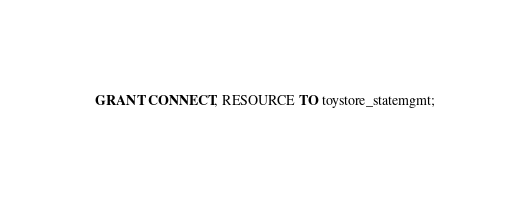<code> <loc_0><loc_0><loc_500><loc_500><_SQL_>
GRANT CONNECT, RESOURCE TO toystore_statemgmt;
</code> 